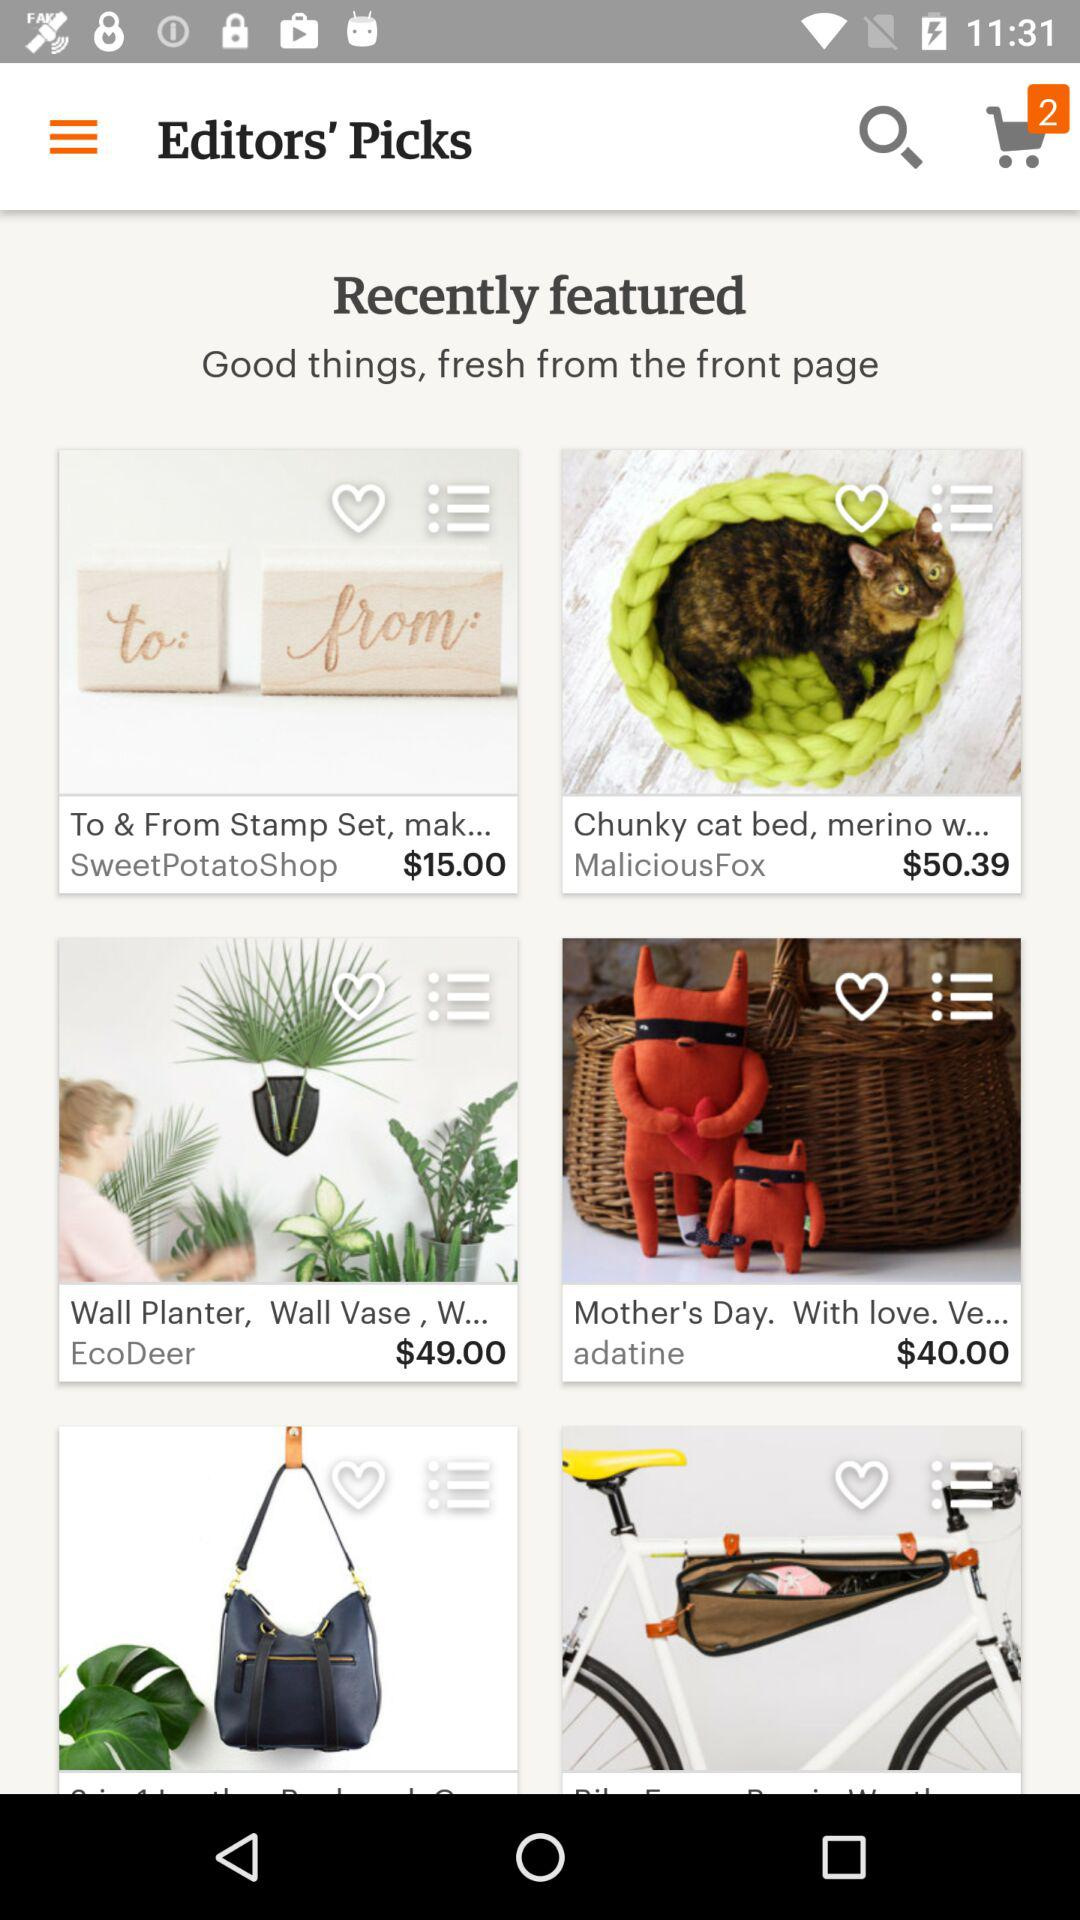What is the price of "Wall Planter"? The price is $49. 